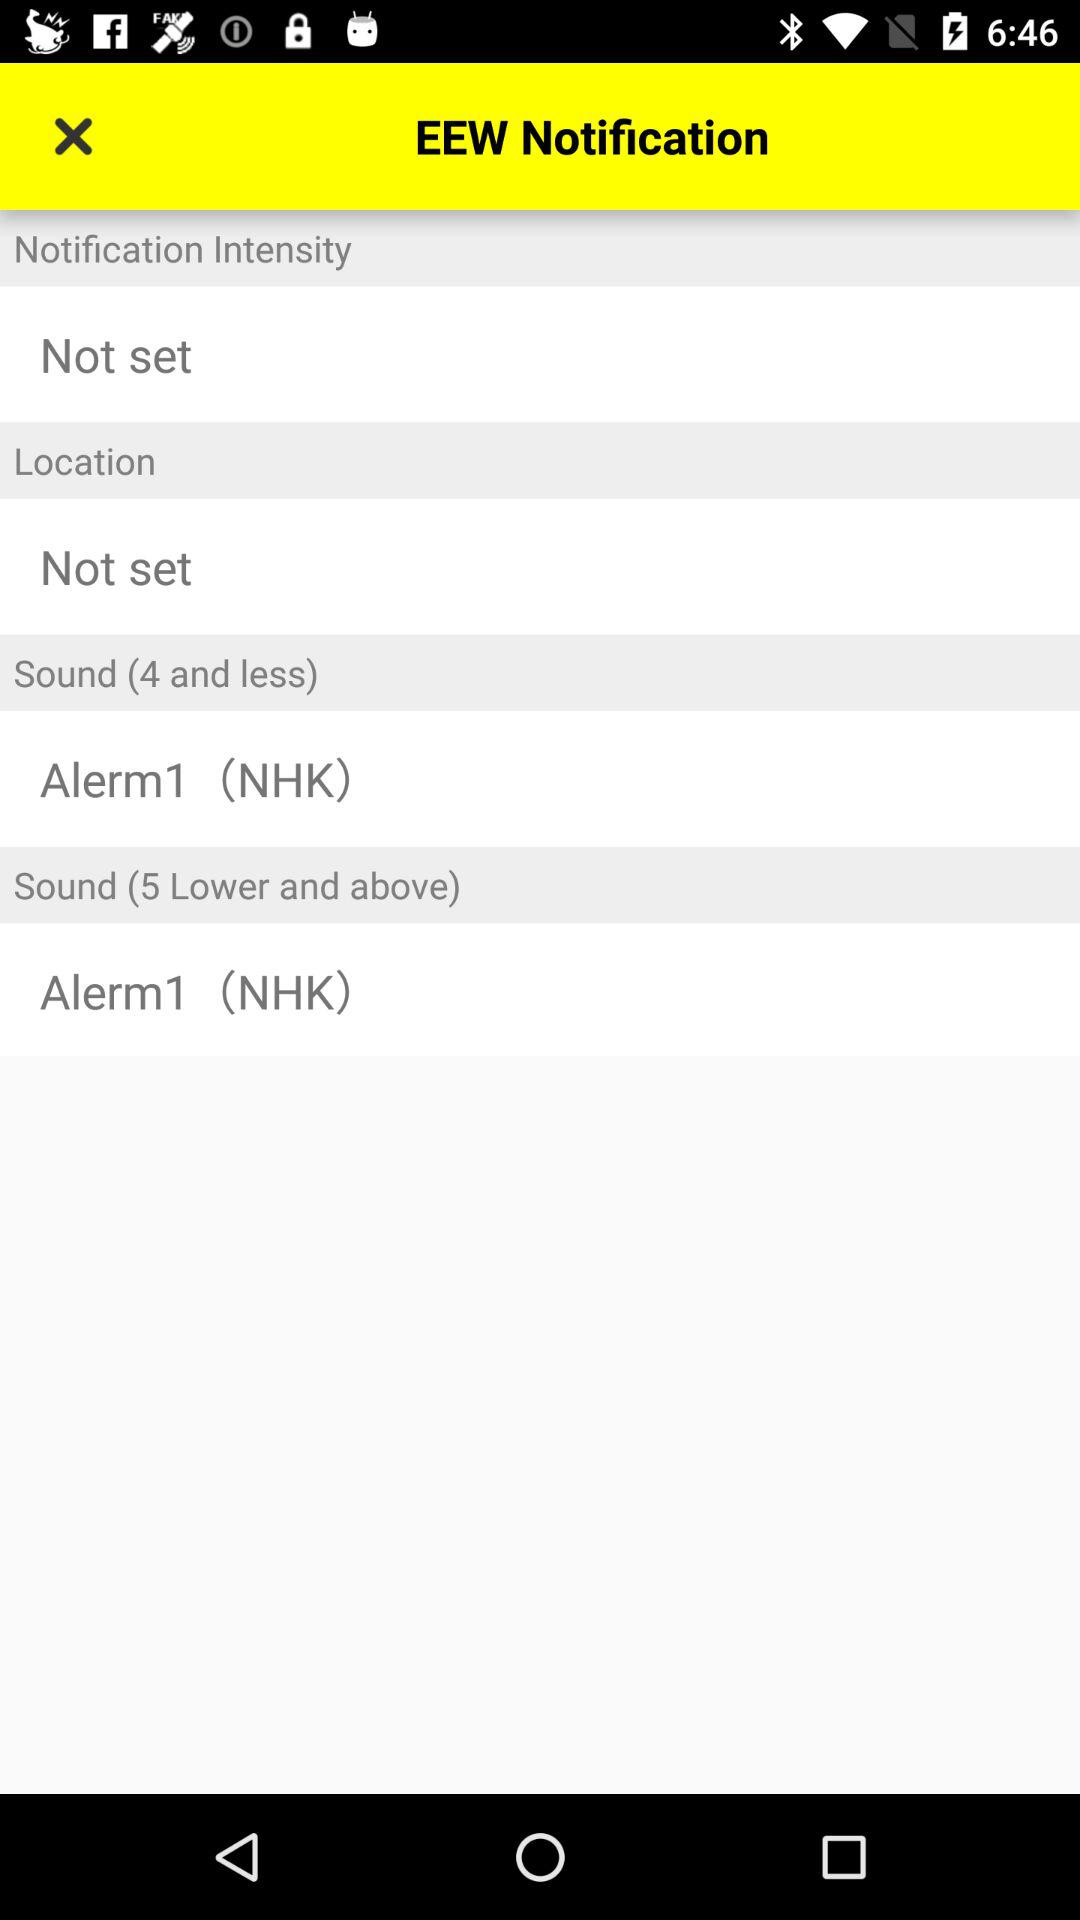How many notification intensity options are there?
Answer the question using a single word or phrase. 2 